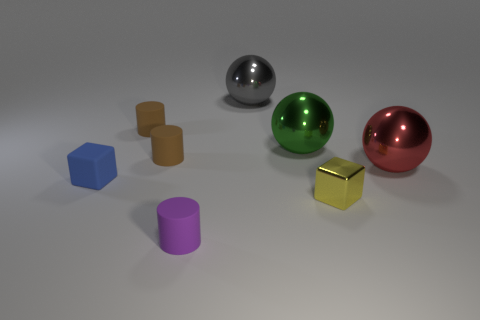Does the small blue block have the same material as the cylinder that is in front of the big red ball? Yes, both the small blue block and the cylinder in front of the big red ball appear to have a matte finish indicating that they may be made of the same or similar materials, which is possibly a type of plastic or painted wood, given their lack of reflective properties compared to the metallic spheres. 